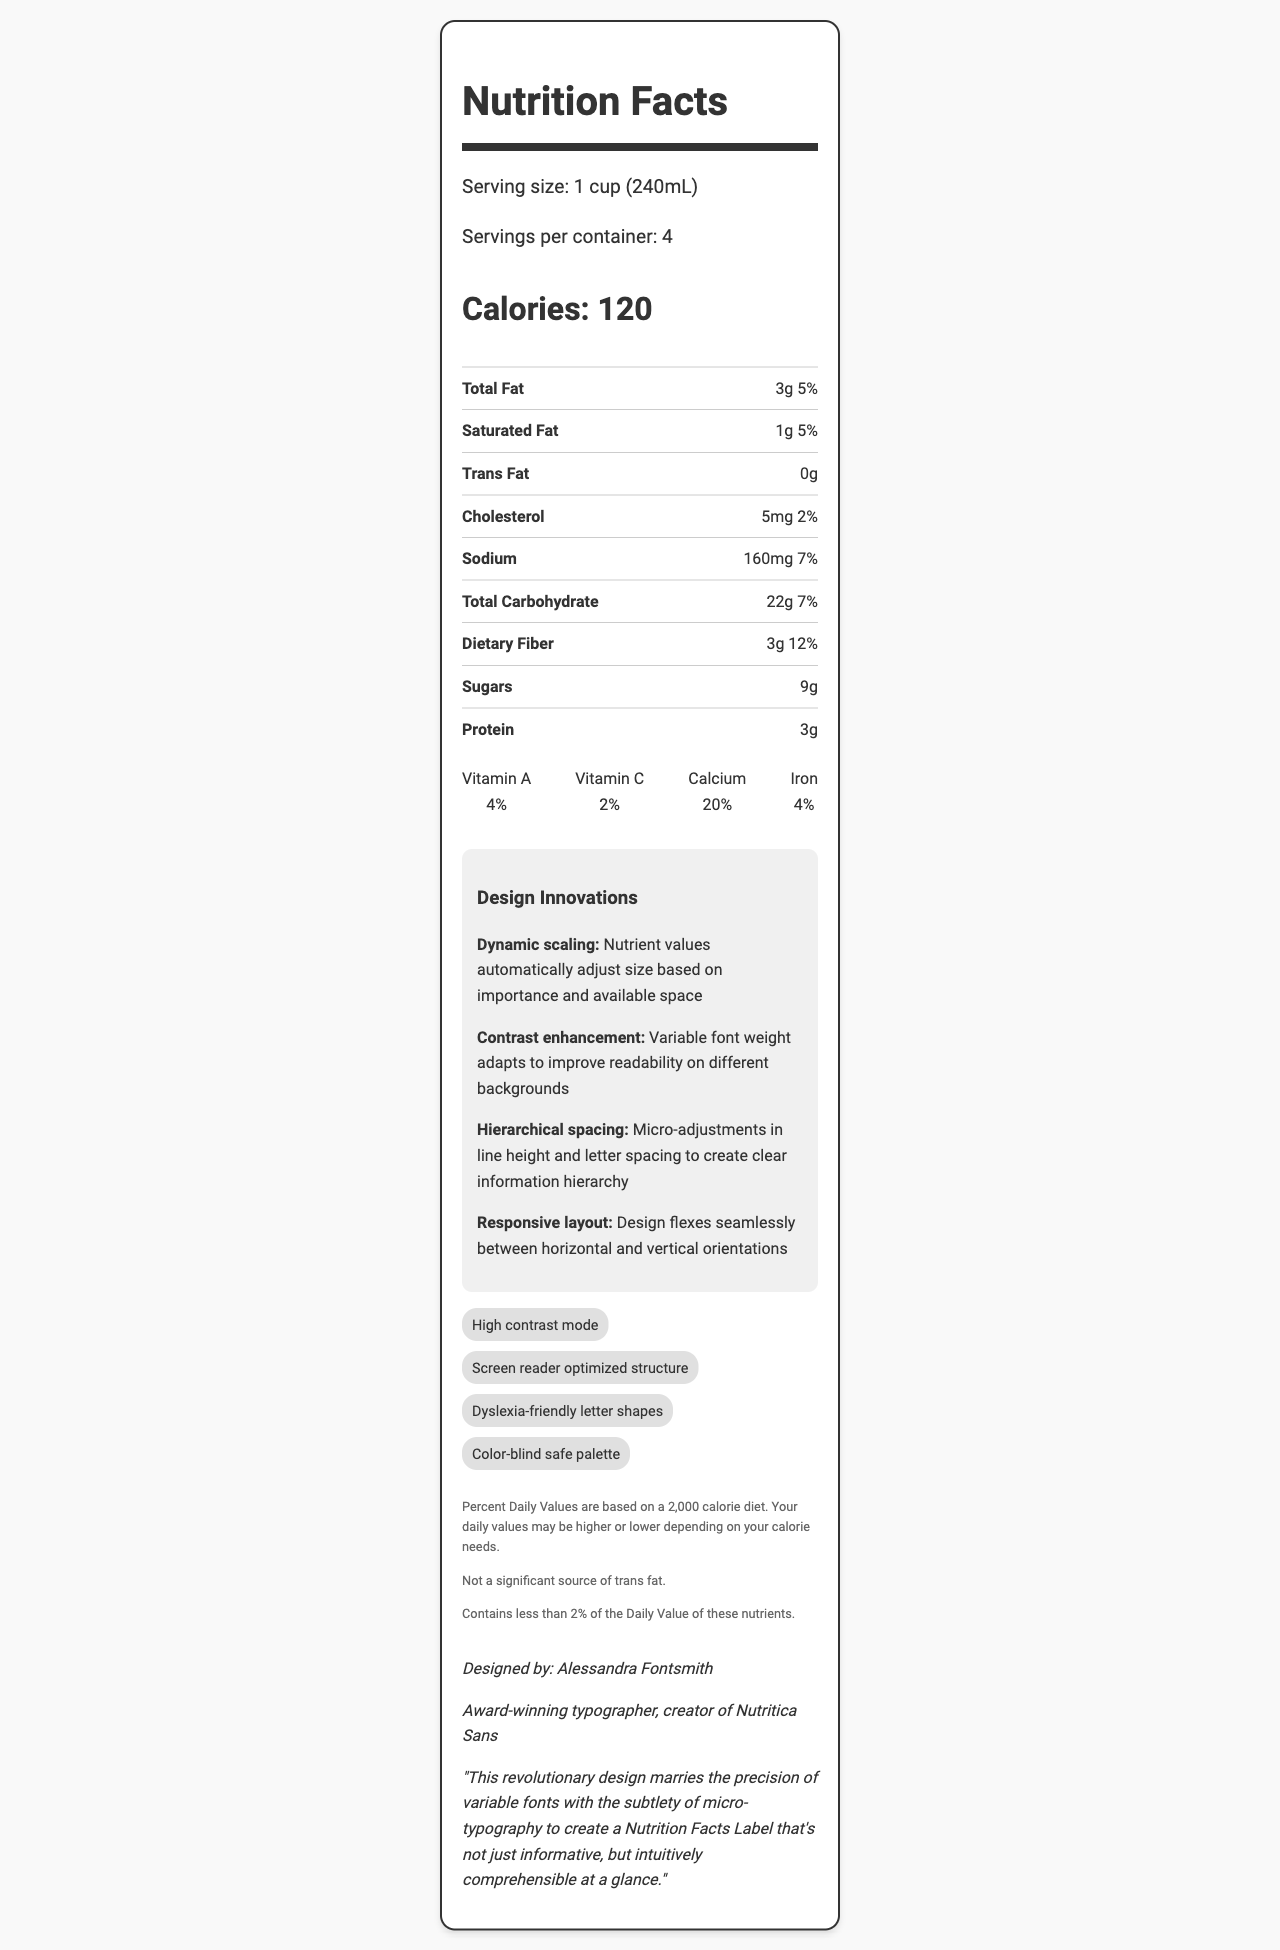What is the serving size for this product? The serving size is clearly listed under the serving information section as "1 cup (240mL)".
Answer: 1 cup (240mL) How many calories are there per serving? The calorie information section states that there are 120 calories per serving.
Answer: 120 What is the percentage of daily value for calcium? Under the vitamins and minerals section, it is noted that the daily value percentage for calcium is 20%.
Answer: 20% Which nutrient has the highest daily value percentage? The nutrient list shows that Dietary Fiber has the highest daily value percentage at 12%.
Answer: Dietary Fiber Who designed this Nutrition Facts Label? The designer information at the bottom of the label states that Alessandra Fontsmith designed the label.
Answer: Alessandra Fontsmith What is one of the primary fonts used in the design? A. Nutritica Sans B. Helvetica C. Arial D. Times New Roman The typographic features section mentions Nutritica Sans as one of the primary fonts used.
Answer: A. Nutritica Sans Which of the following is a design innovation mentioned in the document? I. Dynamic scaling II. Intelligent spacing III. Hierarchical spacing In the design innovations section, dynamic scaling and hierarchical spacing are listed as innovations, while intelligent spacing is not mentioned.
Answer: I, III Does the document mention micro-typography techniques? The typographic features section lists several micro-typography techniques, such as kerning and tracking.
Answer: Yes Summarize the main idea of the Nutrition Facts Label design. The label's design takes a comprehensive approach to improve user experience by employing advanced typography and layout innovations, ensuring the information is clear and accessible to all users.
Answer: The Nutrition Facts Label design focuses on enhancing readability and accessibility through innovative typographic features and micro-typography techniques. Key elements include dynamic scaling, contrast enhancement, hierarchical spacing, and a responsive layout. The design also incorporates high contrast mode, screen reader optimization, dyslexia-friendly shapes, and a color-blind safe palette. What is the exact amount of vitamins in the product? The document lists the daily value percentages for vitamins but does not provide the exact amounts.
Answer: I don't know What type of font weight variation is used to improve readability on different backgrounds? The design innovation section mentions contrast enhancement, stating that variable font weight is used to improve readability on different backgrounds.
Answer: Variable font weight 